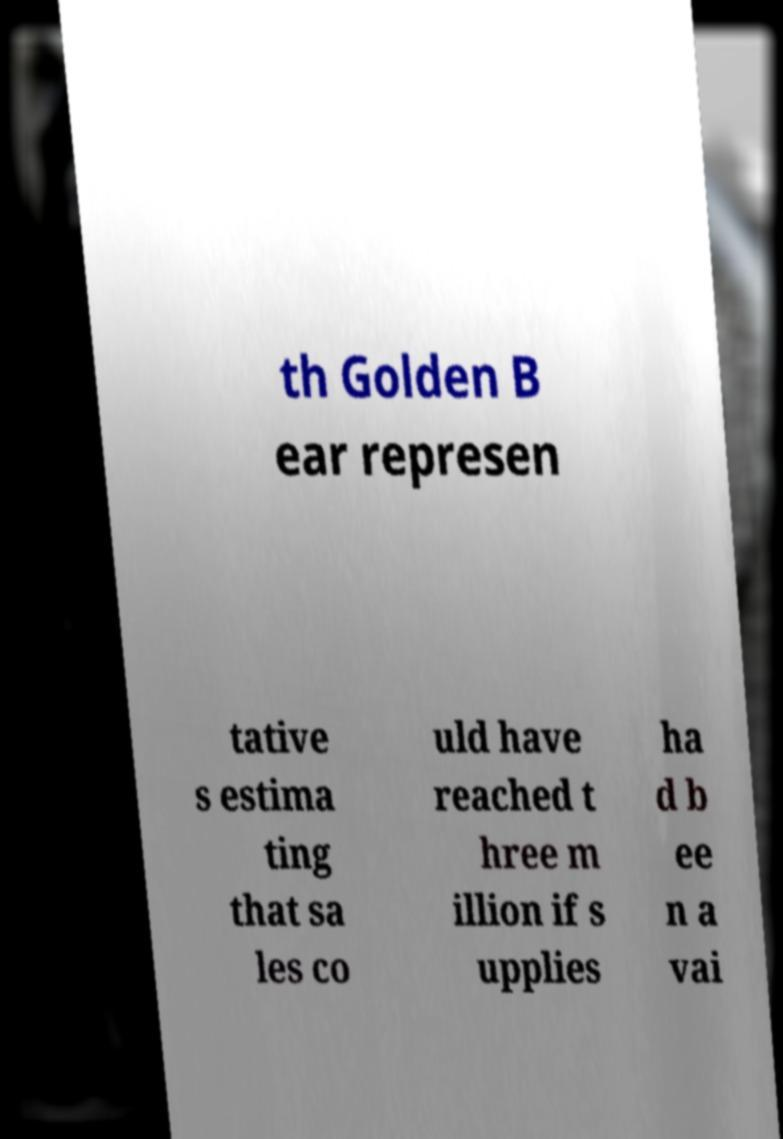Please identify and transcribe the text found in this image. th Golden B ear represen tative s estima ting that sa les co uld have reached t hree m illion if s upplies ha d b ee n a vai 